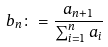Convert formula to latex. <formula><loc_0><loc_0><loc_500><loc_500>b _ { n } \colon = \frac { a _ { n + 1 } } { \sum _ { i = 1 } ^ { n } a _ { i } }</formula> 